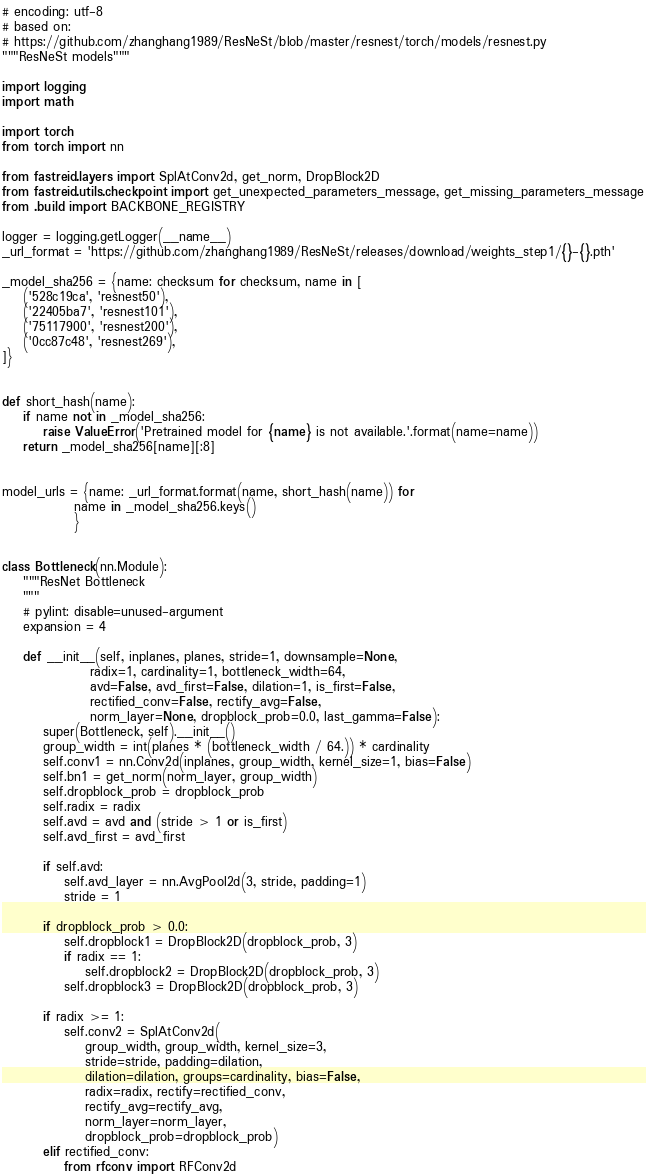Convert code to text. <code><loc_0><loc_0><loc_500><loc_500><_Python_># encoding: utf-8
# based on:
# https://github.com/zhanghang1989/ResNeSt/blob/master/resnest/torch/models/resnest.py
"""ResNeSt models"""

import logging
import math

import torch
from torch import nn

from fastreid.layers import SplAtConv2d, get_norm, DropBlock2D
from fastreid.utils.checkpoint import get_unexpected_parameters_message, get_missing_parameters_message
from .build import BACKBONE_REGISTRY

logger = logging.getLogger(__name__)
_url_format = 'https://github.com/zhanghang1989/ResNeSt/releases/download/weights_step1/{}-{}.pth'

_model_sha256 = {name: checksum for checksum, name in [
    ('528c19ca', 'resnest50'),
    ('22405ba7', 'resnest101'),
    ('75117900', 'resnest200'),
    ('0cc87c48', 'resnest269'),
]}


def short_hash(name):
    if name not in _model_sha256:
        raise ValueError('Pretrained model for {name} is not available.'.format(name=name))
    return _model_sha256[name][:8]


model_urls = {name: _url_format.format(name, short_hash(name)) for
              name in _model_sha256.keys()
              }


class Bottleneck(nn.Module):
    """ResNet Bottleneck
    """
    # pylint: disable=unused-argument
    expansion = 4

    def __init__(self, inplanes, planes, stride=1, downsample=None,
                 radix=1, cardinality=1, bottleneck_width=64,
                 avd=False, avd_first=False, dilation=1, is_first=False,
                 rectified_conv=False, rectify_avg=False,
                 norm_layer=None, dropblock_prob=0.0, last_gamma=False):
        super(Bottleneck, self).__init__()
        group_width = int(planes * (bottleneck_width / 64.)) * cardinality
        self.conv1 = nn.Conv2d(inplanes, group_width, kernel_size=1, bias=False)
        self.bn1 = get_norm(norm_layer, group_width)
        self.dropblock_prob = dropblock_prob
        self.radix = radix
        self.avd = avd and (stride > 1 or is_first)
        self.avd_first = avd_first

        if self.avd:
            self.avd_layer = nn.AvgPool2d(3, stride, padding=1)
            stride = 1

        if dropblock_prob > 0.0:
            self.dropblock1 = DropBlock2D(dropblock_prob, 3)
            if radix == 1:
                self.dropblock2 = DropBlock2D(dropblock_prob, 3)
            self.dropblock3 = DropBlock2D(dropblock_prob, 3)

        if radix >= 1:
            self.conv2 = SplAtConv2d(
                group_width, group_width, kernel_size=3,
                stride=stride, padding=dilation,
                dilation=dilation, groups=cardinality, bias=False,
                radix=radix, rectify=rectified_conv,
                rectify_avg=rectify_avg,
                norm_layer=norm_layer,
                dropblock_prob=dropblock_prob)
        elif rectified_conv:
            from rfconv import RFConv2d</code> 